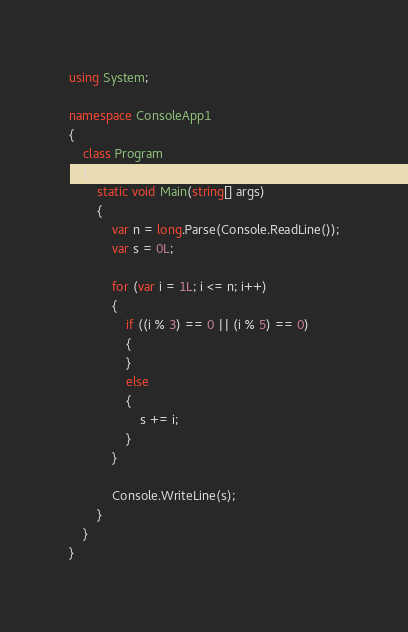<code> <loc_0><loc_0><loc_500><loc_500><_C#_>using System;

namespace ConsoleApp1
{
    class Program
    {
        static void Main(string[] args)
        {
            var n = long.Parse(Console.ReadLine());
            var s = 0L;

            for (var i = 1L; i <= n; i++)
            {
                if ((i % 3) == 0 || (i % 5) == 0)
                {
                }
                else
                {
                    s += i;
                }
            }

            Console.WriteLine(s);
        }
    }
}</code> 